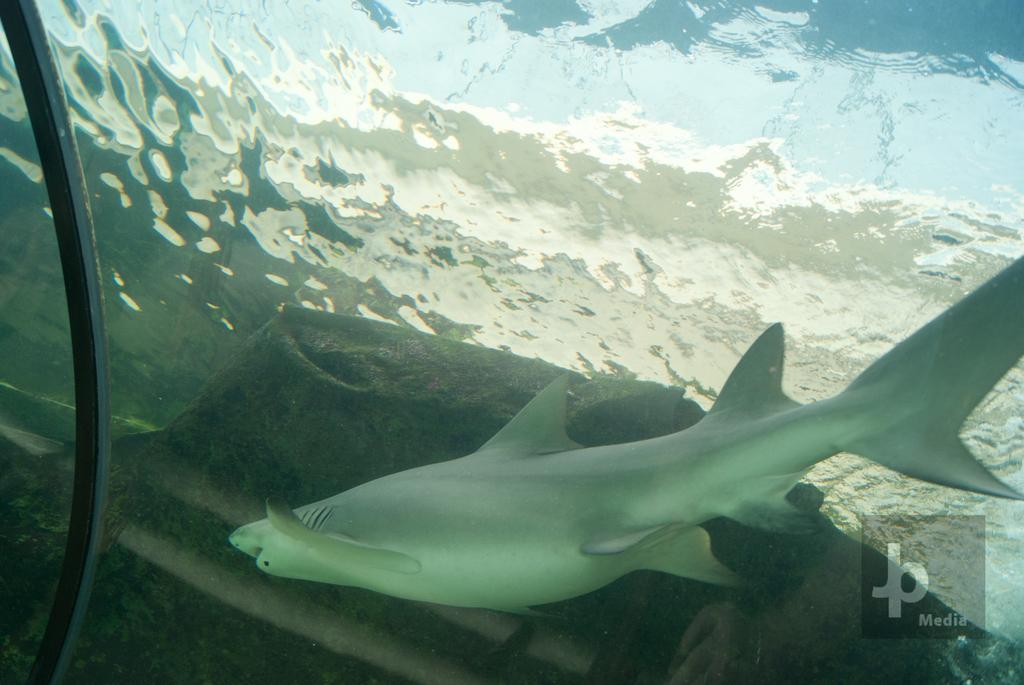What type of animal can be seen in the water in the image? There is a fish in the water in the image. What additional element can be seen in the image? There is a watermark in the corner of the picture. Where are the scissors located in the image? There are no scissors present in the image. What type of insect can be seen crawling on the bed in the image? There is no bed or ants present in the image. 